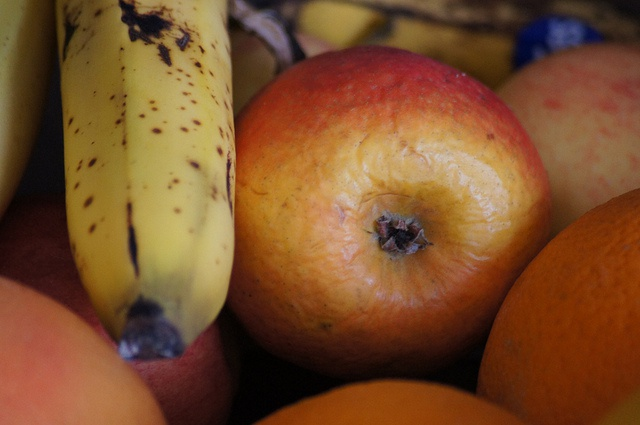Describe the objects in this image and their specific colors. I can see apple in olive, brown, maroon, and tan tones, banana in olive and tan tones, orange in olive and maroon tones, apple in olive, brown, gray, and maroon tones, and apple in olive, red, brown, maroon, and purple tones in this image. 